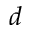<formula> <loc_0><loc_0><loc_500><loc_500>d</formula> 